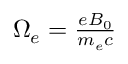<formula> <loc_0><loc_0><loc_500><loc_500>\begin{array} { r } { \Omega _ { e } = \frac { e B _ { 0 } } { m _ { e } c } } \end{array}</formula> 